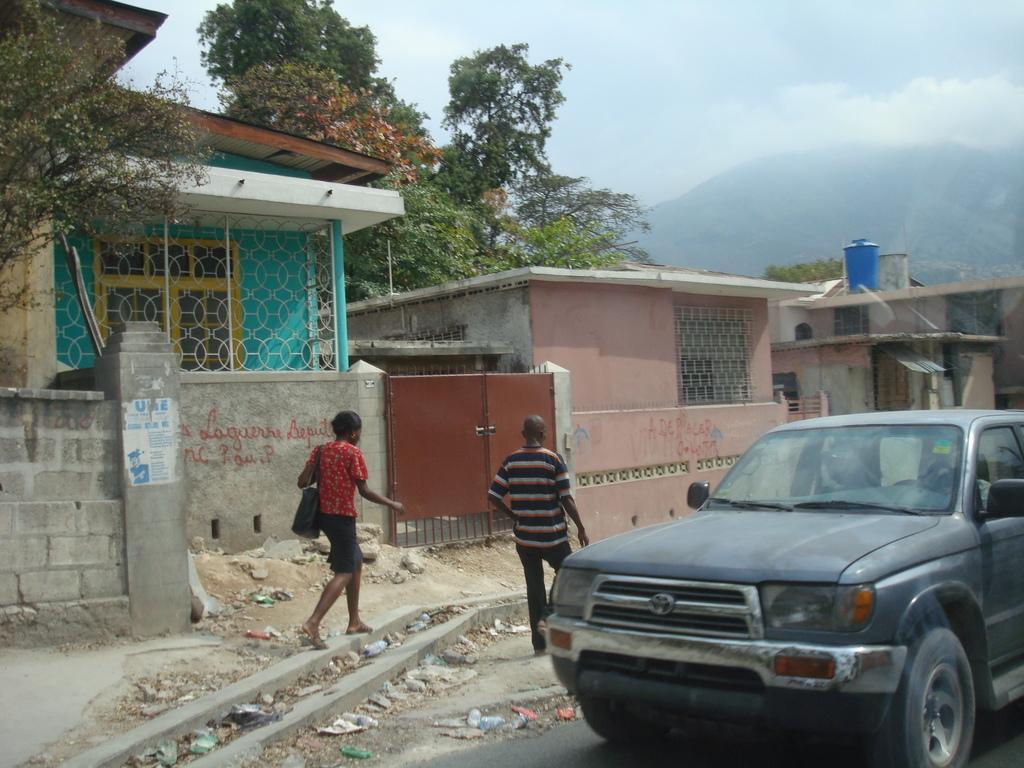How would you summarize this image in a sentence or two? In this picture there are two persons walking and we can see car on the road, houses, poster on the wall, gate, trees and objects. In the background of the image we can see hill and sky. 